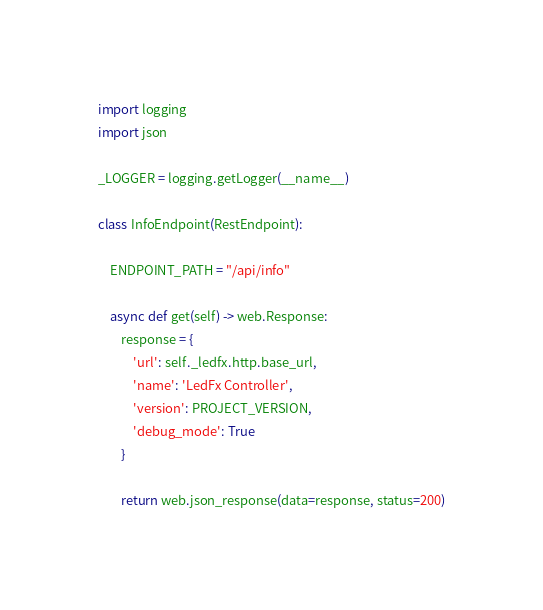<code> <loc_0><loc_0><loc_500><loc_500><_Python_>import logging
import json

_LOGGER = logging.getLogger(__name__)

class InfoEndpoint(RestEndpoint):

    ENDPOINT_PATH = "/api/info"

    async def get(self) -> web.Response:
        response = {
            'url': self._ledfx.http.base_url,
            'name': 'LedFx Controller',
            'version': PROJECT_VERSION,
            'debug_mode': True
        }

        return web.json_response(data=response, status=200)
</code> 